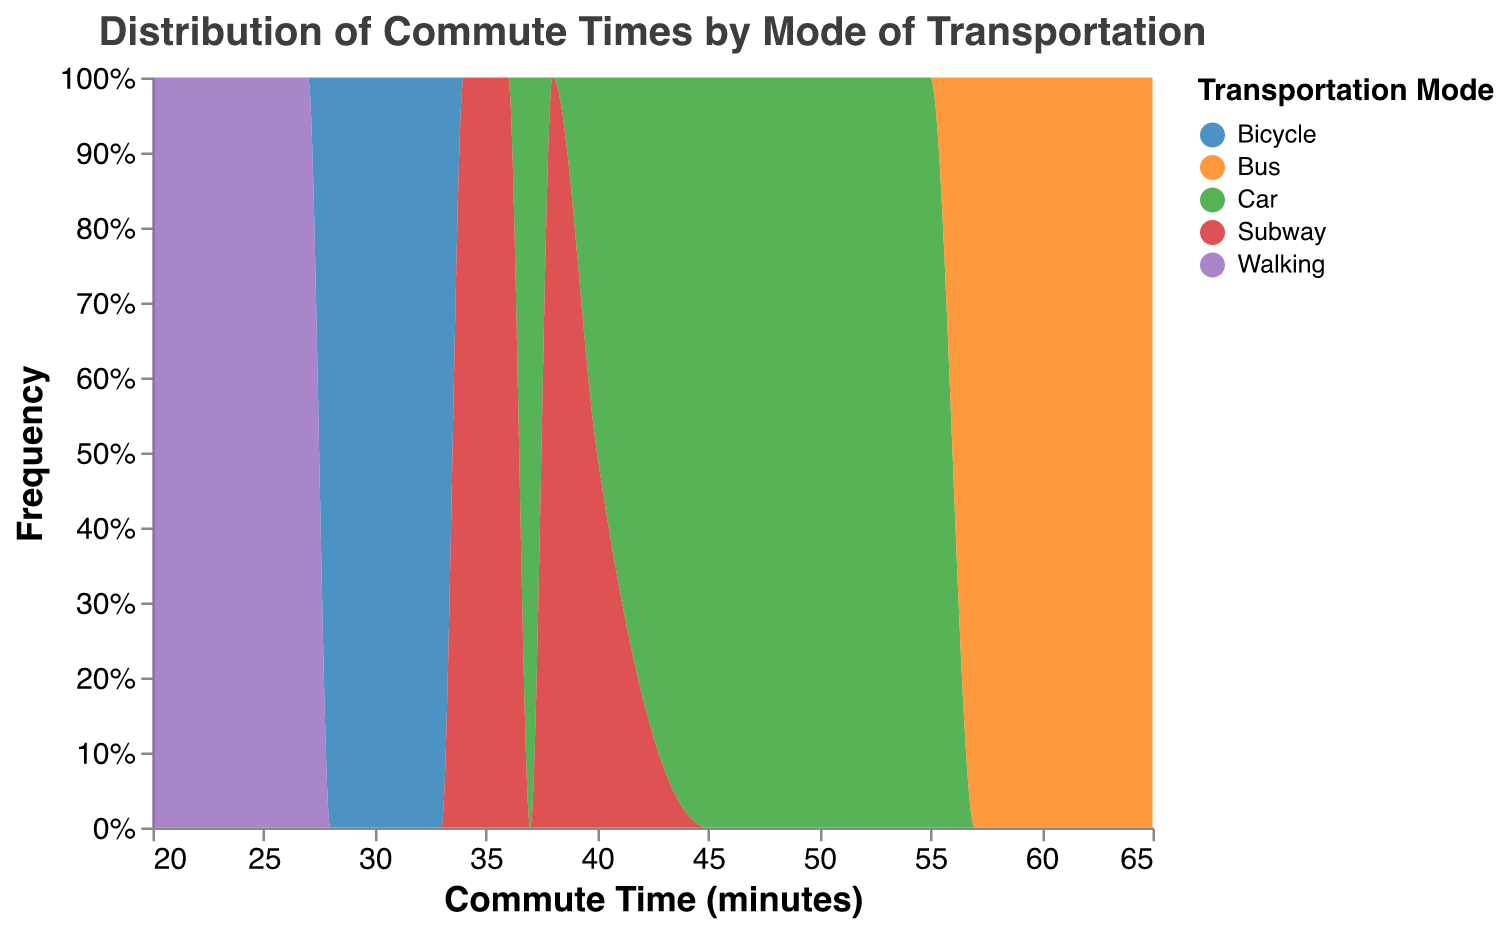What is the title of the figure? The title is typically located at the top of the figure and describes what the plot represents.
Answer: Distribution of Commute Times by Mode of Transportation How many different transportation modes are represented in the figure? The legend on the figure lists all transportation modes represented.
Answer: Five Which transportation mode has the shortest average commute time range? The "Walking" mode has the shortest commute times, ranging from 20 to 27 minutes.
Answer: Walking What is the average commute time for bicycles? The given commute times for bicycles are [30, 28, 33, 32, 29]. By summing and dividing by the number of data points (5), we obtain (30 + 28 + 33 + 32 + 29)/5 = 30.4 minutes.
Answer: 30.4 minutes Which mode of transportation has the most varied commute times? The "Bus" mode shows the most spread-out commute times, ranging from 57 to 65 minutes.
Answer: Bus How do commute times of cars compare to those of subways in terms of range? Cars have commute times from 37 to 55 minutes, while subways have commute times from 34 to 40 minutes. Thus, cars have a wider range.
Answer: Cars have a wider range Which transportation mode seems to have the highest peak frequency in the distplot? By observing the peak heights of the plots, the "Bus" mode appears to have the highest frequency at its peak.
Answer: Bus What is the overall trend observed from the commute times of subways? Subway commute times show a more symmetrical and clustered distribution around 36-38 minutes.
Answer: Consistent and clustered around 36-38 minutes Among the given transportation modes, which one shows the least frequency in the shortest commute time range (20-25 minutes)? The plot shows "Walking" having frequencies in this range, while others do not.
Answer: Least frequency for Car, Bus, Bicycle, Subway What is the total range of commute times represented in the figure? The smallest commute time is 20 minutes (Walking) and the largest is 65 minutes (Bus). So the range is 65 - 20 = 45 minutes.
Answer: 45 minutes 